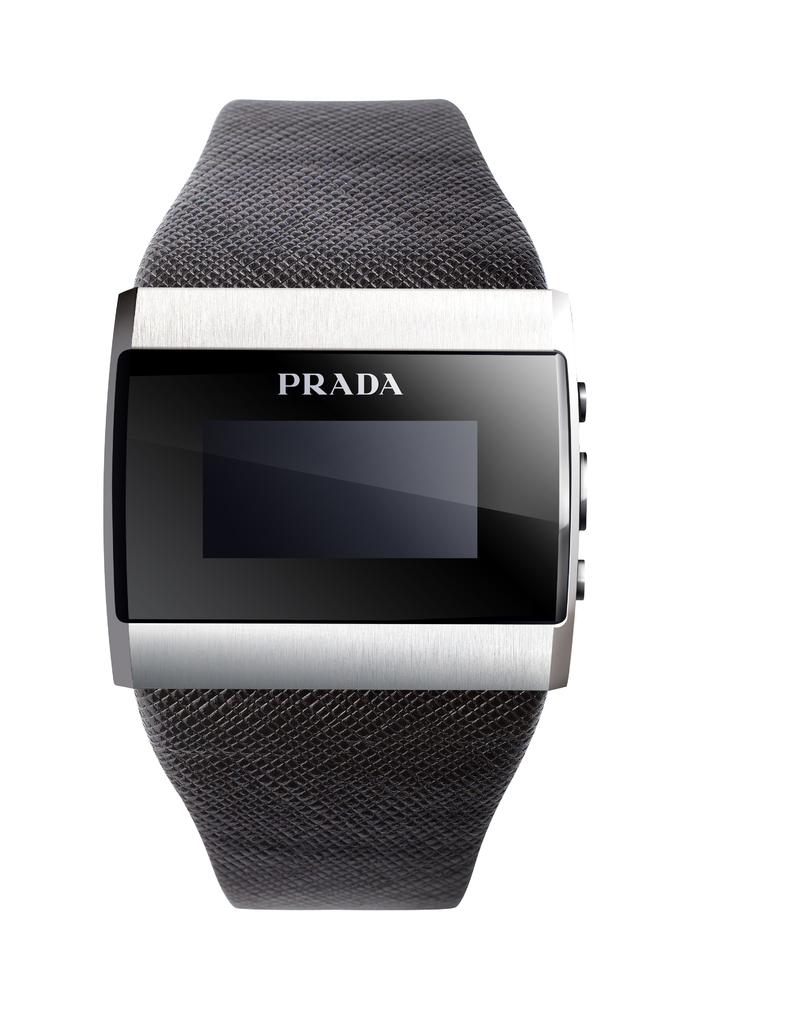<image>
Write a terse but informative summary of the picture. Black wristwatch which says PRADA on the top. 